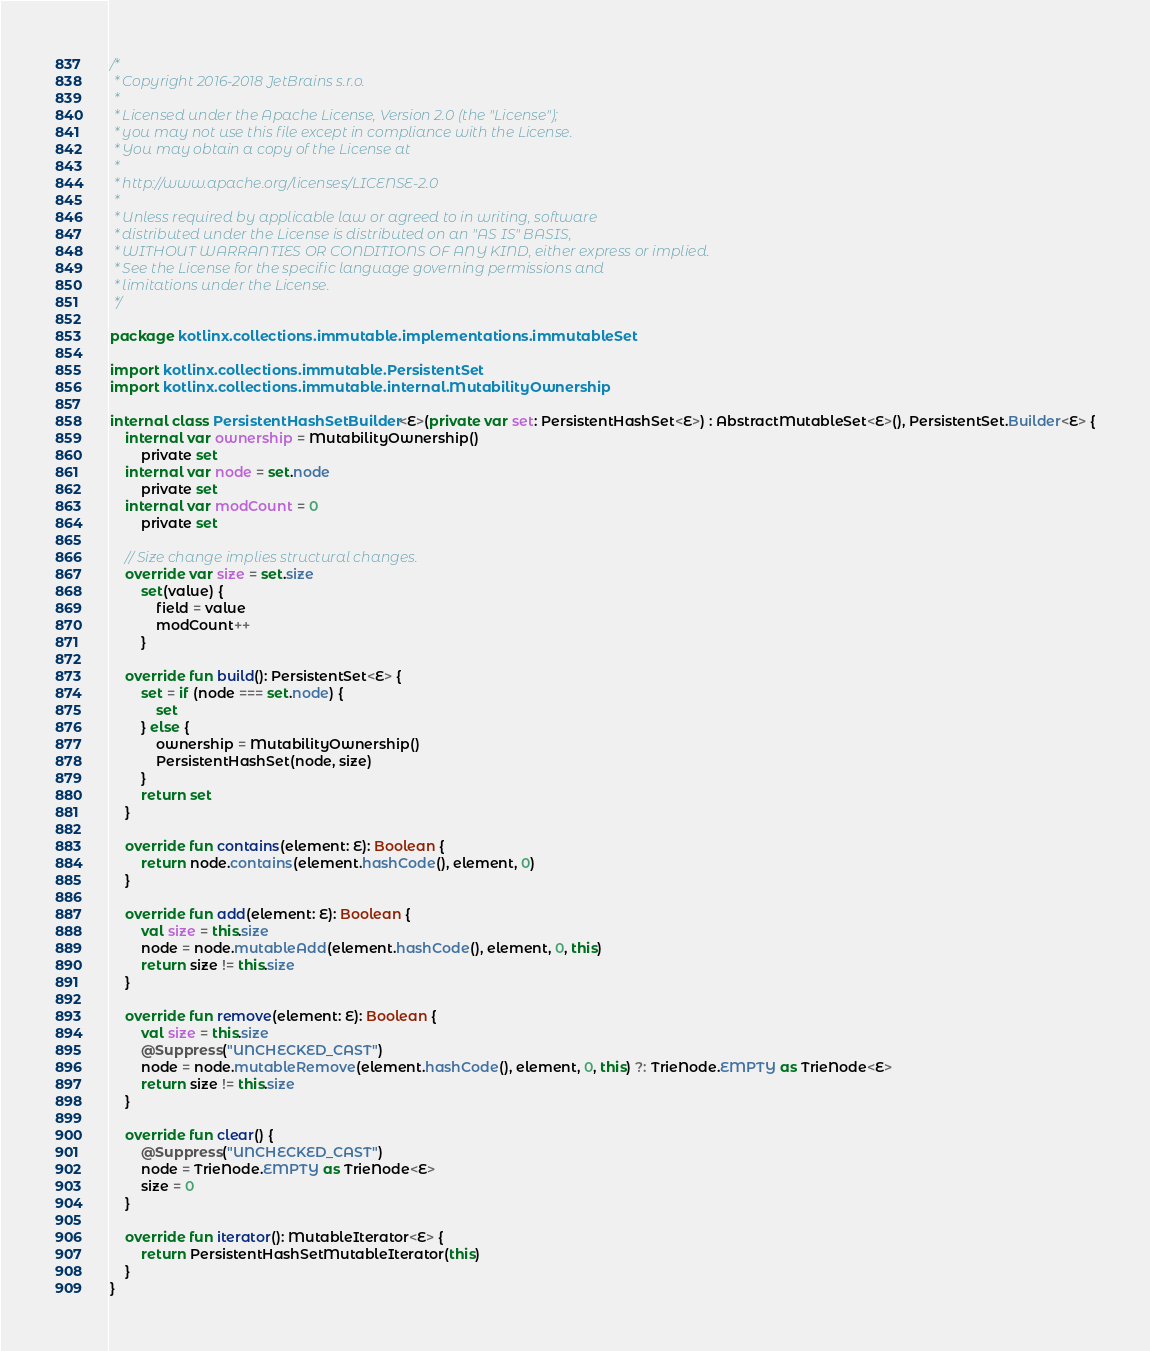<code> <loc_0><loc_0><loc_500><loc_500><_Kotlin_>/*
 * Copyright 2016-2018 JetBrains s.r.o.
 *
 * Licensed under the Apache License, Version 2.0 (the "License");
 * you may not use this file except in compliance with the License.
 * You may obtain a copy of the License at
 *
 * http://www.apache.org/licenses/LICENSE-2.0
 *
 * Unless required by applicable law or agreed to in writing, software
 * distributed under the License is distributed on an "AS IS" BASIS,
 * WITHOUT WARRANTIES OR CONDITIONS OF ANY KIND, either express or implied.
 * See the License for the specific language governing permissions and
 * limitations under the License.
 */

package kotlinx.collections.immutable.implementations.immutableSet

import kotlinx.collections.immutable.PersistentSet
import kotlinx.collections.immutable.internal.MutabilityOwnership

internal class PersistentHashSetBuilder<E>(private var set: PersistentHashSet<E>) : AbstractMutableSet<E>(), PersistentSet.Builder<E> {
    internal var ownership = MutabilityOwnership()
        private set
    internal var node = set.node
        private set
    internal var modCount = 0
        private set

    // Size change implies structural changes.
    override var size = set.size
        set(value) {
            field = value
            modCount++
        }

    override fun build(): PersistentSet<E> {
        set = if (node === set.node) {
            set
        } else {
            ownership = MutabilityOwnership()
            PersistentHashSet(node, size)
        }
        return set
    }

    override fun contains(element: E): Boolean {
        return node.contains(element.hashCode(), element, 0)
    }

    override fun add(element: E): Boolean {
        val size = this.size
        node = node.mutableAdd(element.hashCode(), element, 0, this)
        return size != this.size
    }

    override fun remove(element: E): Boolean {
        val size = this.size
        @Suppress("UNCHECKED_CAST")
        node = node.mutableRemove(element.hashCode(), element, 0, this) ?: TrieNode.EMPTY as TrieNode<E>
        return size != this.size
    }

    override fun clear() {
        @Suppress("UNCHECKED_CAST")
        node = TrieNode.EMPTY as TrieNode<E>
        size = 0
    }

    override fun iterator(): MutableIterator<E> {
        return PersistentHashSetMutableIterator(this)
    }
}</code> 